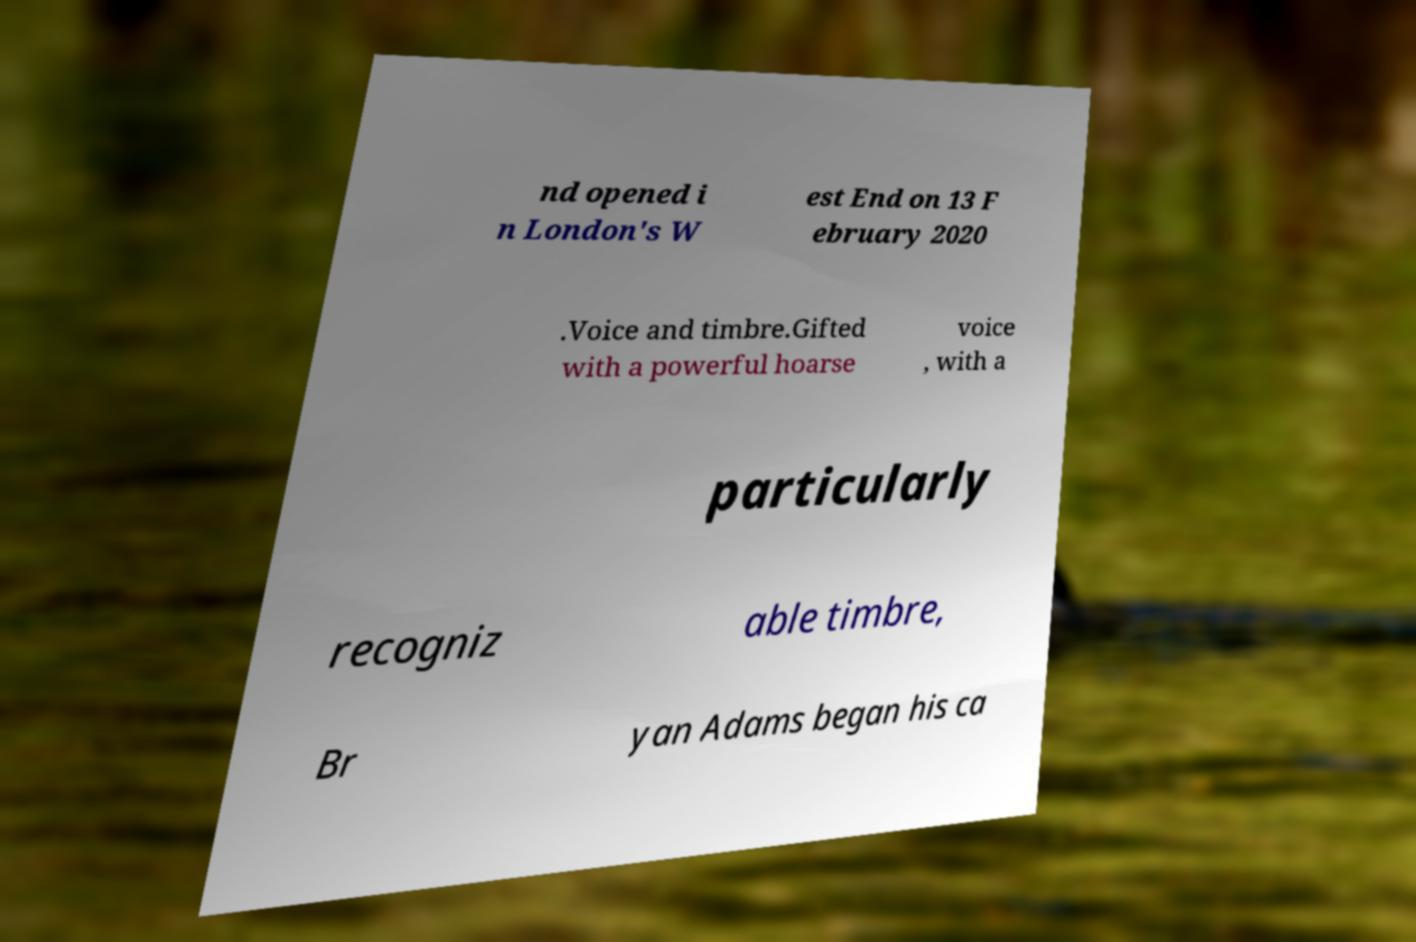Can you read and provide the text displayed in the image?This photo seems to have some interesting text. Can you extract and type it out for me? nd opened i n London's W est End on 13 F ebruary 2020 .Voice and timbre.Gifted with a powerful hoarse voice , with a particularly recogniz able timbre, Br yan Adams began his ca 